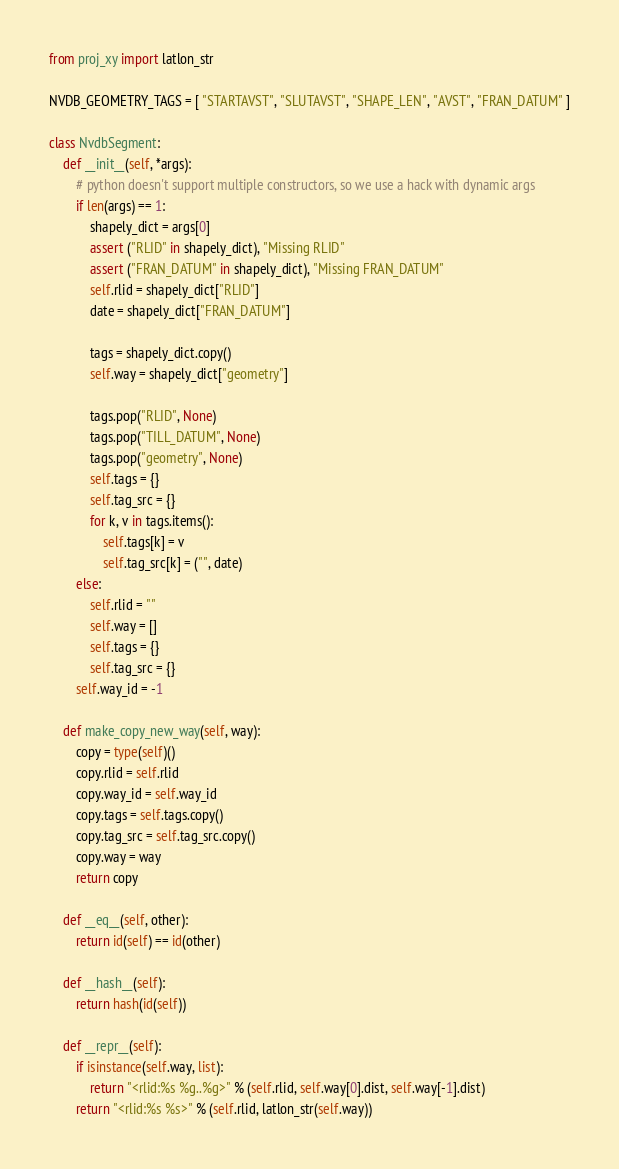Convert code to text. <code><loc_0><loc_0><loc_500><loc_500><_Python_>from proj_xy import latlon_str

NVDB_GEOMETRY_TAGS = [ "STARTAVST", "SLUTAVST", "SHAPE_LEN", "AVST", "FRAN_DATUM" ]

class NvdbSegment:
    def __init__(self, *args):
        # python doesn't support multiple constructors, so we use a hack with dynamic args
        if len(args) == 1:
            shapely_dict = args[0]
            assert ("RLID" in shapely_dict), "Missing RLID"
            assert ("FRAN_DATUM" in shapely_dict), "Missing FRAN_DATUM"
            self.rlid = shapely_dict["RLID"]
            date = shapely_dict["FRAN_DATUM"]

            tags = shapely_dict.copy()
            self.way = shapely_dict["geometry"]

            tags.pop("RLID", None)
            tags.pop("TILL_DATUM", None)
            tags.pop("geometry", None)
            self.tags = {}
            self.tag_src = {}
            for k, v in tags.items():
                self.tags[k] = v
                self.tag_src[k] = ("", date)
        else:
            self.rlid = ""
            self.way = []
            self.tags = {}
            self.tag_src = {}
        self.way_id = -1

    def make_copy_new_way(self, way):
        copy = type(self)()
        copy.rlid = self.rlid
        copy.way_id = self.way_id
        copy.tags = self.tags.copy()
        copy.tag_src = self.tag_src.copy()
        copy.way = way
        return copy

    def __eq__(self, other):
        return id(self) == id(other)

    def __hash__(self):
        return hash(id(self))

    def __repr__(self):
        if isinstance(self.way, list):
            return "<rlid:%s %g..%g>" % (self.rlid, self.way[0].dist, self.way[-1].dist)
        return "<rlid:%s %s>" % (self.rlid, latlon_str(self.way))
</code> 